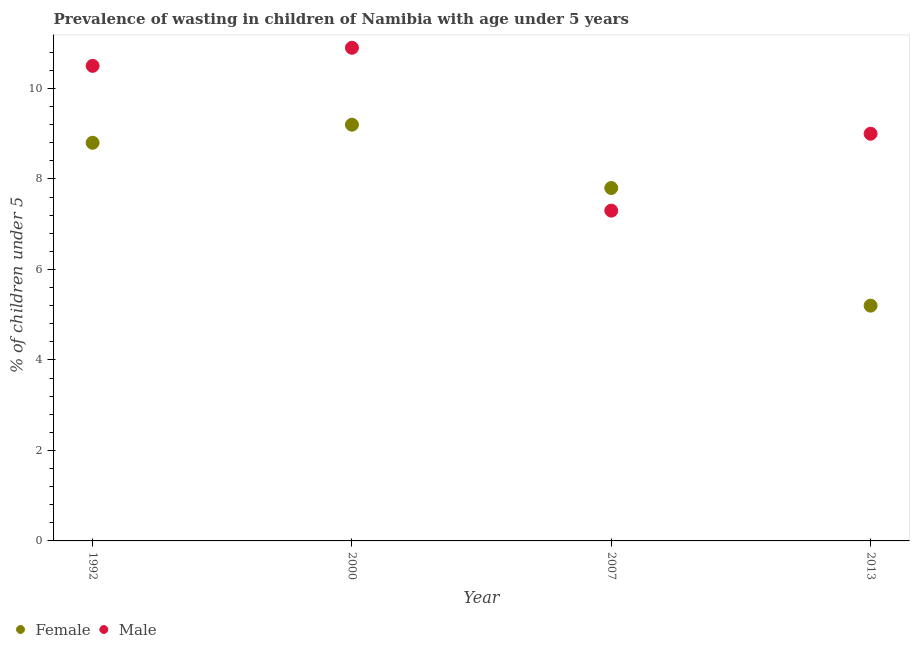How many different coloured dotlines are there?
Provide a short and direct response. 2. Across all years, what is the maximum percentage of undernourished female children?
Your answer should be very brief. 9.2. Across all years, what is the minimum percentage of undernourished male children?
Keep it short and to the point. 7.3. In which year was the percentage of undernourished female children maximum?
Provide a short and direct response. 2000. What is the total percentage of undernourished female children in the graph?
Your response must be concise. 31. What is the difference between the percentage of undernourished male children in 2000 and that in 2007?
Ensure brevity in your answer.  3.6. What is the difference between the percentage of undernourished female children in 2007 and the percentage of undernourished male children in 2013?
Offer a very short reply. -1.2. What is the average percentage of undernourished male children per year?
Your answer should be very brief. 9.42. In the year 2013, what is the difference between the percentage of undernourished female children and percentage of undernourished male children?
Give a very brief answer. -3.8. In how many years, is the percentage of undernourished female children greater than 8.4 %?
Give a very brief answer. 2. What is the ratio of the percentage of undernourished male children in 2000 to that in 2007?
Make the answer very short. 1.49. Is the percentage of undernourished male children in 2000 less than that in 2013?
Give a very brief answer. No. Is the difference between the percentage of undernourished male children in 2000 and 2013 greater than the difference between the percentage of undernourished female children in 2000 and 2013?
Your answer should be compact. No. What is the difference between the highest and the second highest percentage of undernourished female children?
Provide a short and direct response. 0.4. What is the difference between the highest and the lowest percentage of undernourished female children?
Your answer should be very brief. 4. In how many years, is the percentage of undernourished male children greater than the average percentage of undernourished male children taken over all years?
Your answer should be very brief. 2. Does the percentage of undernourished female children monotonically increase over the years?
Give a very brief answer. No. How many dotlines are there?
Your response must be concise. 2. How many years are there in the graph?
Offer a terse response. 4. Does the graph contain any zero values?
Keep it short and to the point. No. Where does the legend appear in the graph?
Your response must be concise. Bottom left. How many legend labels are there?
Provide a succinct answer. 2. What is the title of the graph?
Your answer should be very brief. Prevalence of wasting in children of Namibia with age under 5 years. What is the label or title of the X-axis?
Offer a terse response. Year. What is the label or title of the Y-axis?
Keep it short and to the point.  % of children under 5. What is the  % of children under 5 of Female in 1992?
Give a very brief answer. 8.8. What is the  % of children under 5 of Female in 2000?
Give a very brief answer. 9.2. What is the  % of children under 5 of Male in 2000?
Keep it short and to the point. 10.9. What is the  % of children under 5 in Female in 2007?
Your response must be concise. 7.8. What is the  % of children under 5 in Male in 2007?
Keep it short and to the point. 7.3. What is the  % of children under 5 of Female in 2013?
Your answer should be very brief. 5.2. Across all years, what is the maximum  % of children under 5 of Female?
Keep it short and to the point. 9.2. Across all years, what is the maximum  % of children under 5 of Male?
Your response must be concise. 10.9. Across all years, what is the minimum  % of children under 5 in Female?
Keep it short and to the point. 5.2. Across all years, what is the minimum  % of children under 5 of Male?
Provide a short and direct response. 7.3. What is the total  % of children under 5 of Female in the graph?
Give a very brief answer. 31. What is the total  % of children under 5 of Male in the graph?
Your answer should be very brief. 37.7. What is the difference between the  % of children under 5 of Male in 1992 and that in 2007?
Your response must be concise. 3.2. What is the difference between the  % of children under 5 in Female in 2000 and that in 2007?
Provide a short and direct response. 1.4. What is the difference between the  % of children under 5 of Female in 2000 and that in 2013?
Offer a very short reply. 4. What is the difference between the  % of children under 5 of Male in 2000 and that in 2013?
Your answer should be very brief. 1.9. What is the difference between the  % of children under 5 of Female in 1992 and the  % of children under 5 of Male in 2000?
Give a very brief answer. -2.1. What is the difference between the  % of children under 5 of Female in 2000 and the  % of children under 5 of Male in 2007?
Make the answer very short. 1.9. What is the average  % of children under 5 in Female per year?
Your answer should be very brief. 7.75. What is the average  % of children under 5 of Male per year?
Your response must be concise. 9.43. What is the ratio of the  % of children under 5 in Female in 1992 to that in 2000?
Offer a very short reply. 0.96. What is the ratio of the  % of children under 5 of Male in 1992 to that in 2000?
Provide a short and direct response. 0.96. What is the ratio of the  % of children under 5 of Female in 1992 to that in 2007?
Ensure brevity in your answer.  1.13. What is the ratio of the  % of children under 5 of Male in 1992 to that in 2007?
Your answer should be compact. 1.44. What is the ratio of the  % of children under 5 of Female in 1992 to that in 2013?
Provide a succinct answer. 1.69. What is the ratio of the  % of children under 5 in Male in 1992 to that in 2013?
Make the answer very short. 1.17. What is the ratio of the  % of children under 5 in Female in 2000 to that in 2007?
Provide a succinct answer. 1.18. What is the ratio of the  % of children under 5 of Male in 2000 to that in 2007?
Your answer should be very brief. 1.49. What is the ratio of the  % of children under 5 in Female in 2000 to that in 2013?
Your response must be concise. 1.77. What is the ratio of the  % of children under 5 of Male in 2000 to that in 2013?
Provide a short and direct response. 1.21. What is the ratio of the  % of children under 5 of Male in 2007 to that in 2013?
Make the answer very short. 0.81. What is the difference between the highest and the second highest  % of children under 5 in Female?
Provide a succinct answer. 0.4. What is the difference between the highest and the second highest  % of children under 5 in Male?
Your answer should be compact. 0.4. What is the difference between the highest and the lowest  % of children under 5 in Male?
Make the answer very short. 3.6. 